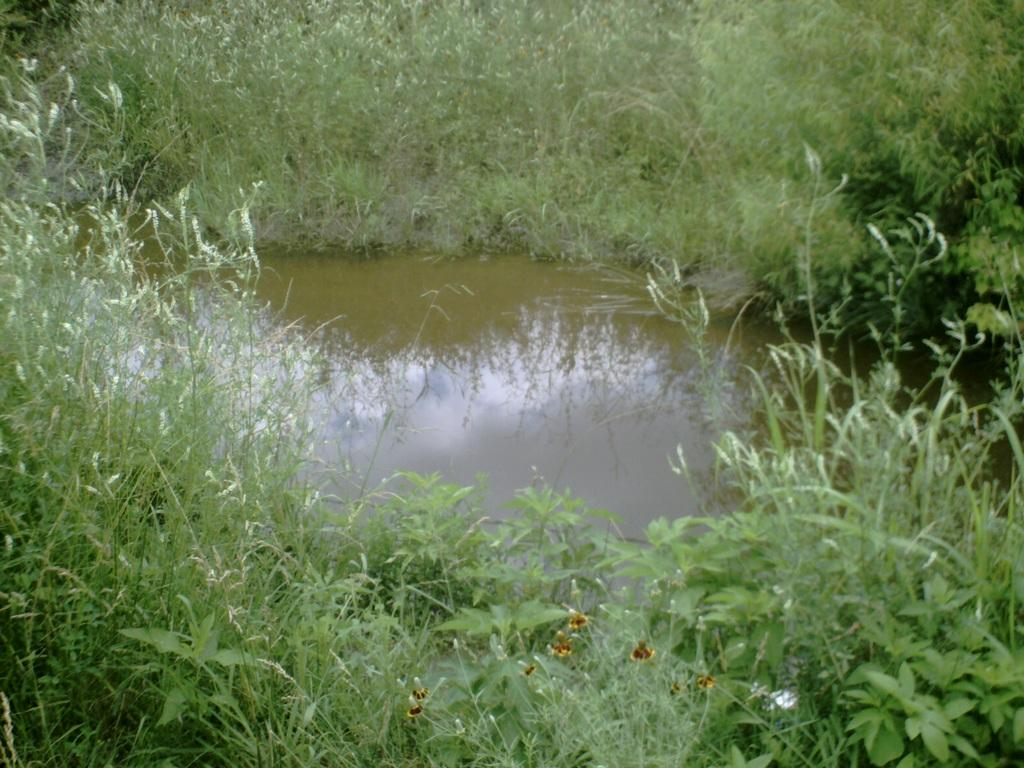What is the main feature in the center of the image? There is a pond in the center of the image. What type of vegetation can be seen at the bottom of the image? There is grass at the bottom of the image. Are there any other plants visible in the image besides the grass? Yes, there are plants visible in the image. How many apples are hanging from the plants in the image? There are no apples present in the image; it features a pond, grass, and other plants. What type of pen is being used to draw the plants in the image? There is no pen or drawing activity present in the image; it is a photograph of a pond, grass, and plants. 